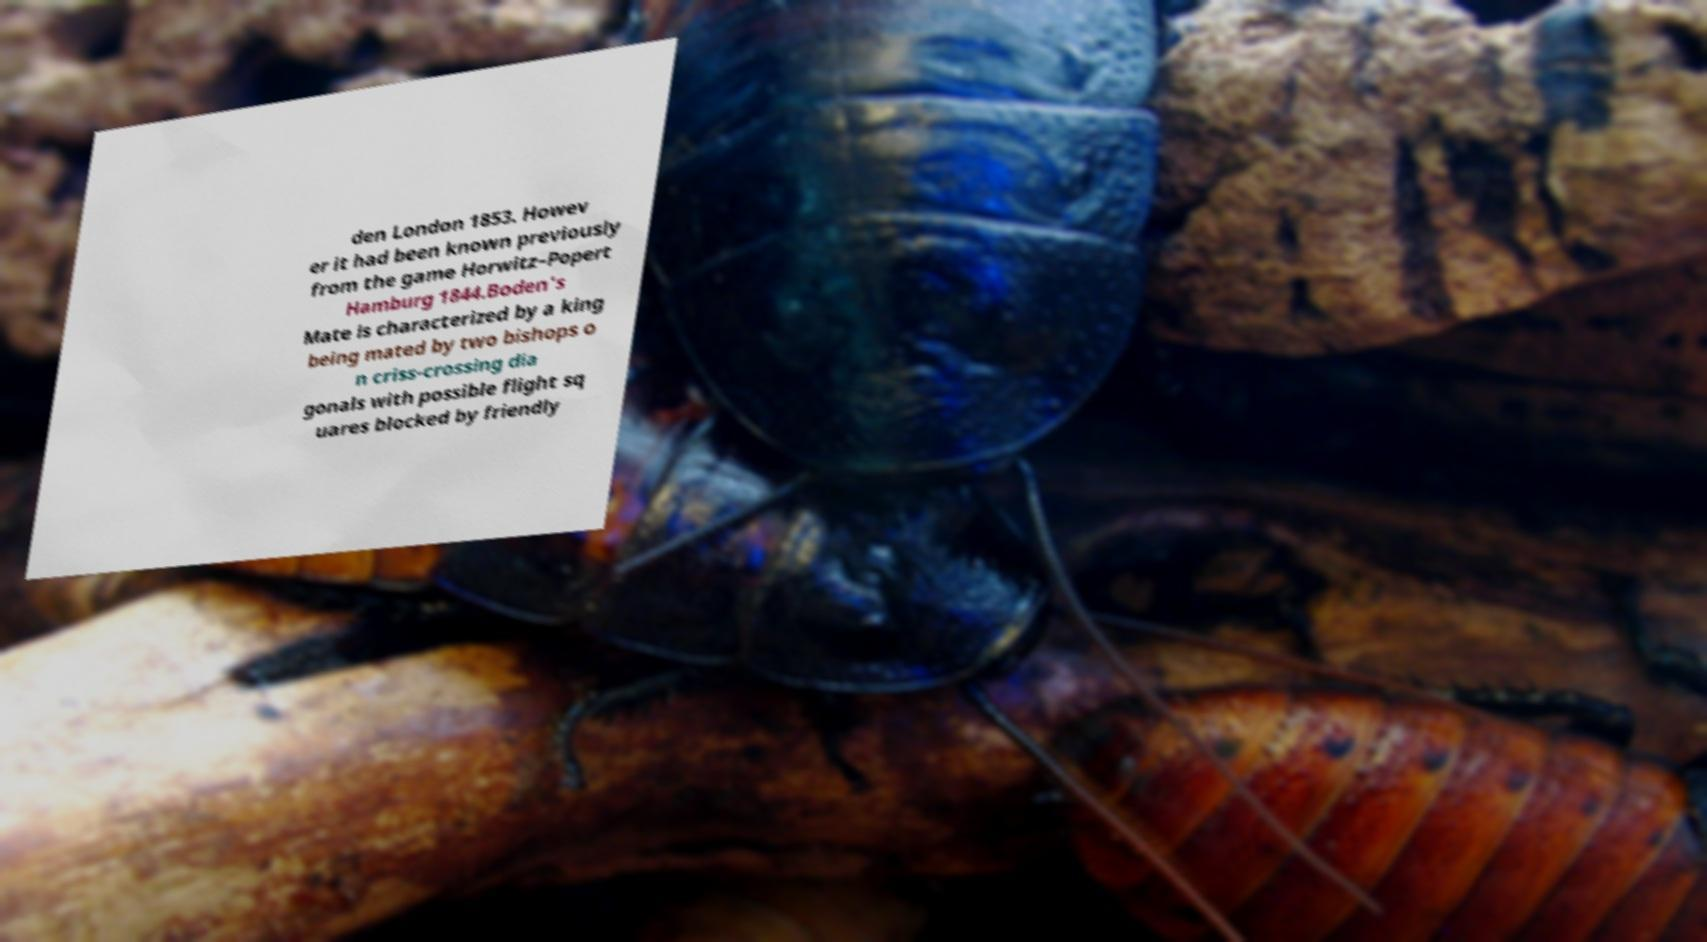Could you assist in decoding the text presented in this image and type it out clearly? den London 1853. Howev er it had been known previously from the game Horwitz–Popert Hamburg 1844.Boden's Mate is characterized by a king being mated by two bishops o n criss-crossing dia gonals with possible flight sq uares blocked by friendly 